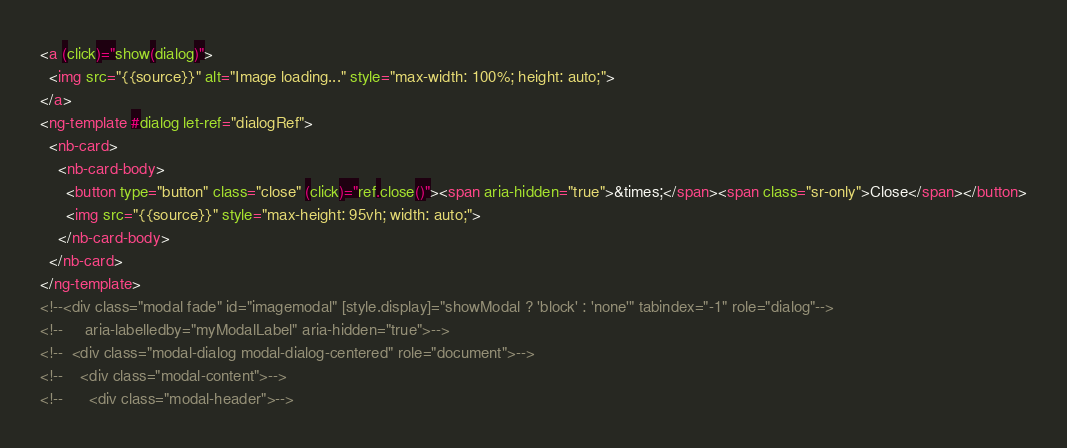Convert code to text. <code><loc_0><loc_0><loc_500><loc_500><_HTML_><a (click)="show(dialog)">
  <img src="{{source}}" alt="Image loading..." style="max-width: 100%; height: auto;">
</a>
<ng-template #dialog let-ref="dialogRef">
  <nb-card>
    <nb-card-body>
      <button type="button" class="close" (click)="ref.close()"><span aria-hidden="true">&times;</span><span class="sr-only">Close</span></button>
      <img src="{{source}}" style="max-height: 95vh; width: auto;">
    </nb-card-body>
  </nb-card>
</ng-template>
<!--<div class="modal fade" id="imagemodal" [style.display]="showModal ? 'block' : 'none'" tabindex="-1" role="dialog"-->
<!--     aria-labelledby="myModalLabel" aria-hidden="true">-->
<!--  <div class="modal-dialog modal-dialog-centered" role="document">-->
<!--    <div class="modal-content">-->
<!--      <div class="modal-header">--></code> 